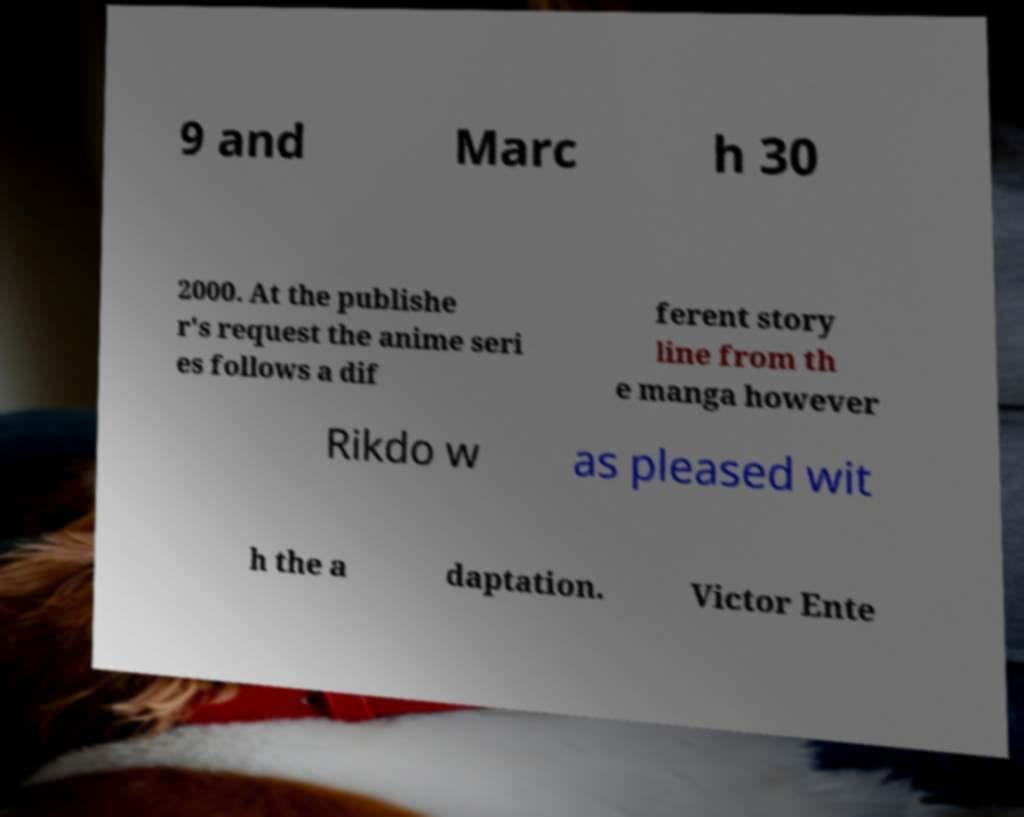Can you accurately transcribe the text from the provided image for me? 9 and Marc h 30 2000. At the publishe r's request the anime seri es follows a dif ferent story line from th e manga however Rikdo w as pleased wit h the a daptation. Victor Ente 